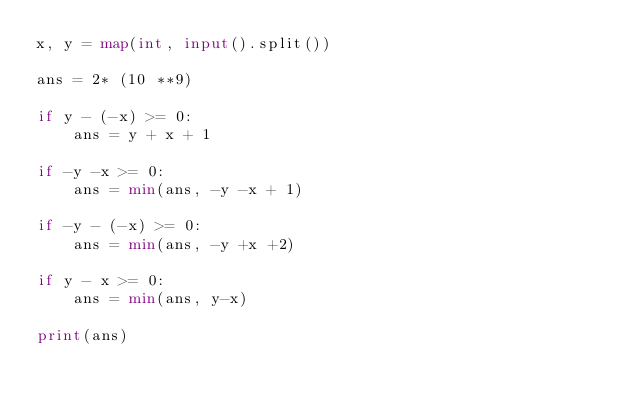Convert code to text. <code><loc_0><loc_0><loc_500><loc_500><_Python_>x, y = map(int, input().split())

ans = 2* (10 **9)

if y - (-x) >= 0:
    ans = y + x + 1

if -y -x >= 0:
    ans = min(ans, -y -x + 1)

if -y - (-x) >= 0:
    ans = min(ans, -y +x +2)

if y - x >= 0:
    ans = min(ans, y-x)

print(ans)</code> 